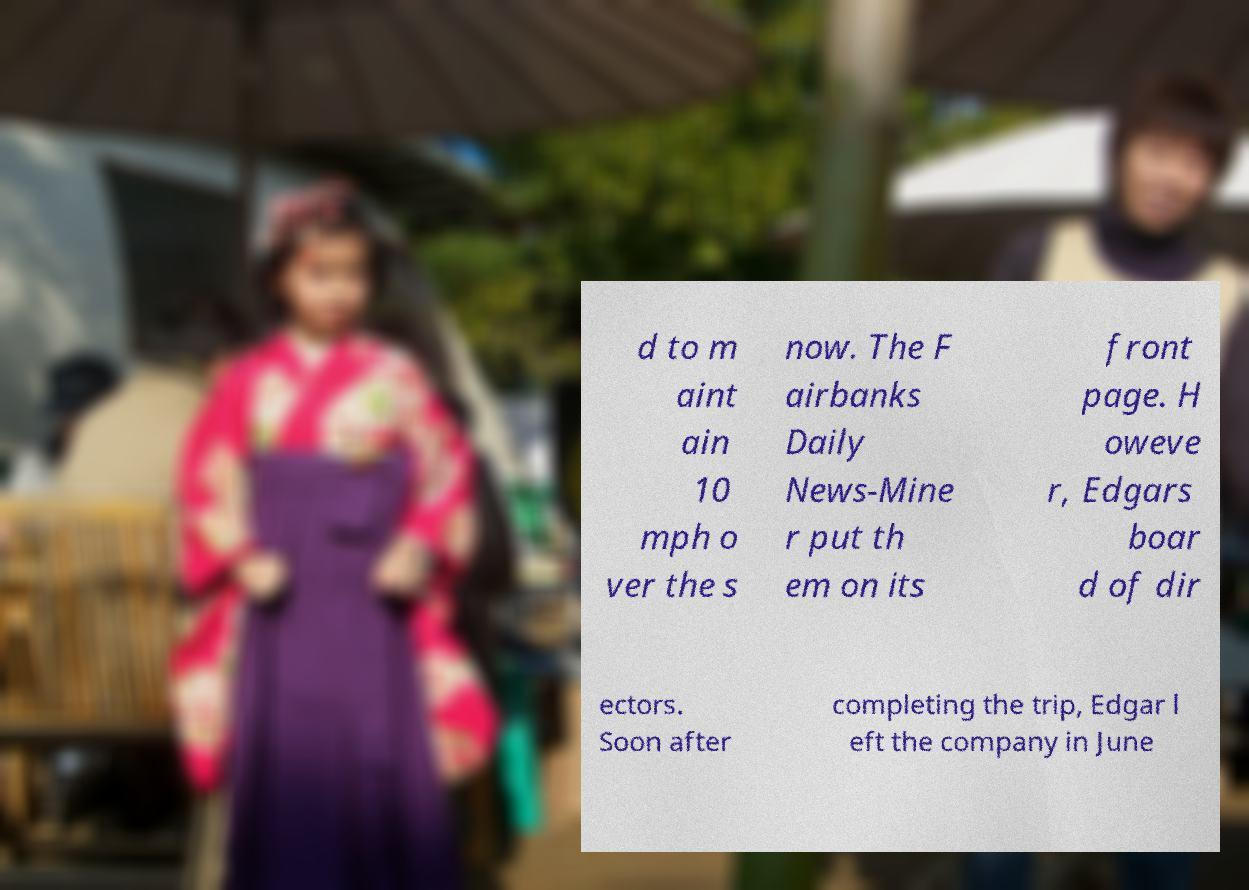Could you assist in decoding the text presented in this image and type it out clearly? d to m aint ain 10 mph o ver the s now. The F airbanks Daily News-Mine r put th em on its front page. H oweve r, Edgars boar d of dir ectors. Soon after completing the trip, Edgar l eft the company in June 